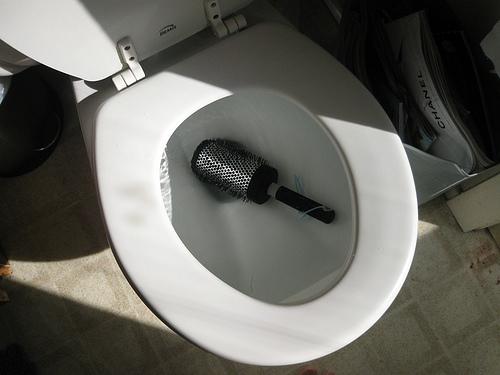What kind of floor is in the photo?
Give a very brief answer. Tile. What color is the toilet?
Concise answer only. White. Would this make the brush clean or dirty?
Keep it brief. Dirty. 